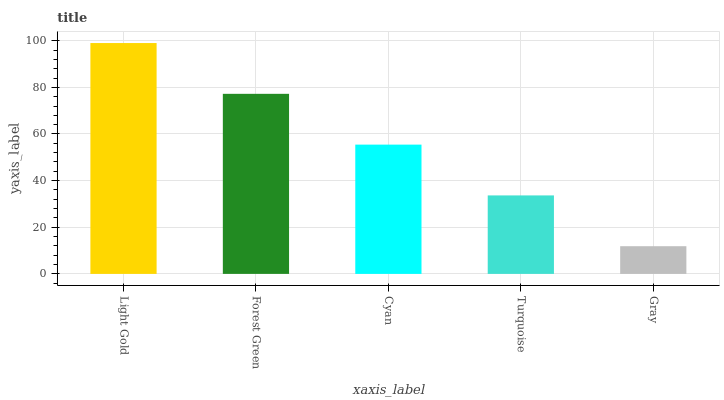Is Gray the minimum?
Answer yes or no. Yes. Is Light Gold the maximum?
Answer yes or no. Yes. Is Forest Green the minimum?
Answer yes or no. No. Is Forest Green the maximum?
Answer yes or no. No. Is Light Gold greater than Forest Green?
Answer yes or no. Yes. Is Forest Green less than Light Gold?
Answer yes or no. Yes. Is Forest Green greater than Light Gold?
Answer yes or no. No. Is Light Gold less than Forest Green?
Answer yes or no. No. Is Cyan the high median?
Answer yes or no. Yes. Is Cyan the low median?
Answer yes or no. Yes. Is Forest Green the high median?
Answer yes or no. No. Is Gray the low median?
Answer yes or no. No. 